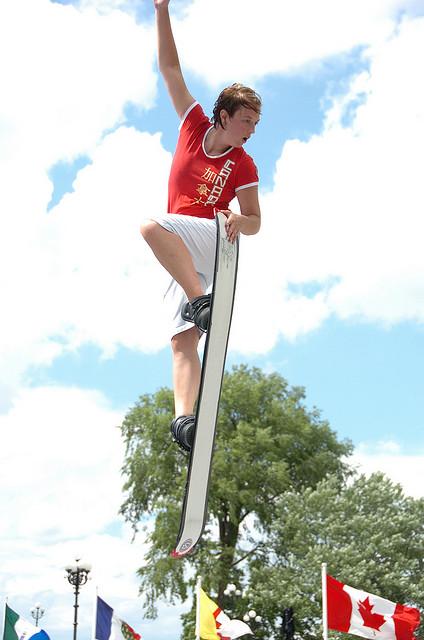Are there a lot of clouds in the sky?
Be succinct. Yes. What flag is in the bottom right corner?
Short answer required. Canadian. Does she have her feet on the ground?
Be succinct. No. 